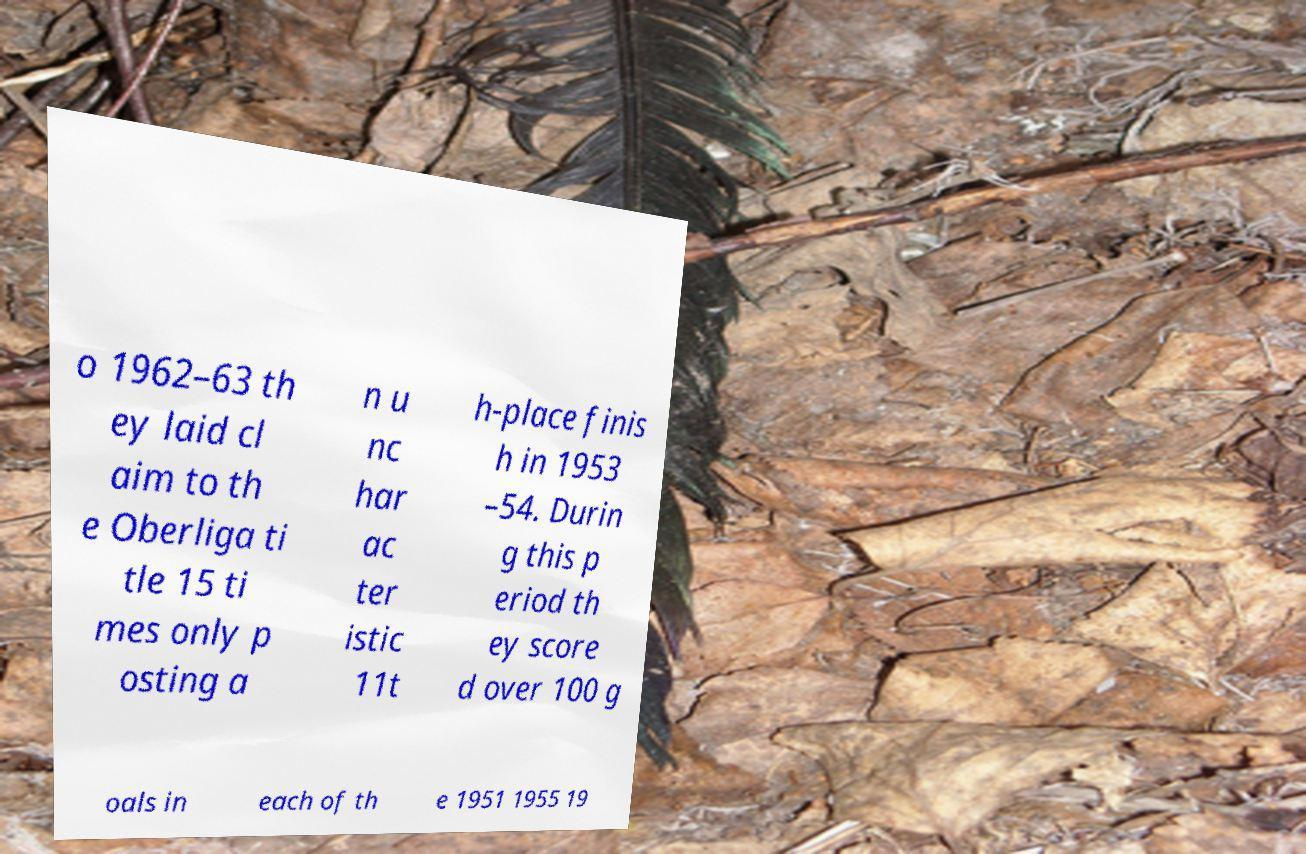Can you read and provide the text displayed in the image?This photo seems to have some interesting text. Can you extract and type it out for me? o 1962–63 th ey laid cl aim to th e Oberliga ti tle 15 ti mes only p osting a n u nc har ac ter istic 11t h-place finis h in 1953 –54. Durin g this p eriod th ey score d over 100 g oals in each of th e 1951 1955 19 